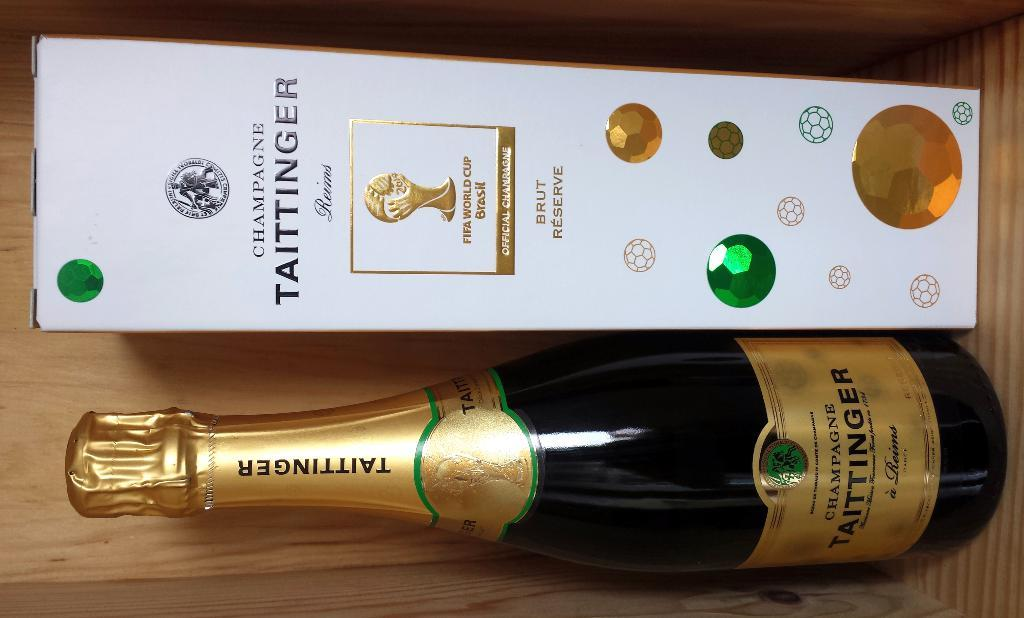<image>
Render a clear and concise summary of the photo. a champaign bottle lays next to a box that says Taittinger on it. 